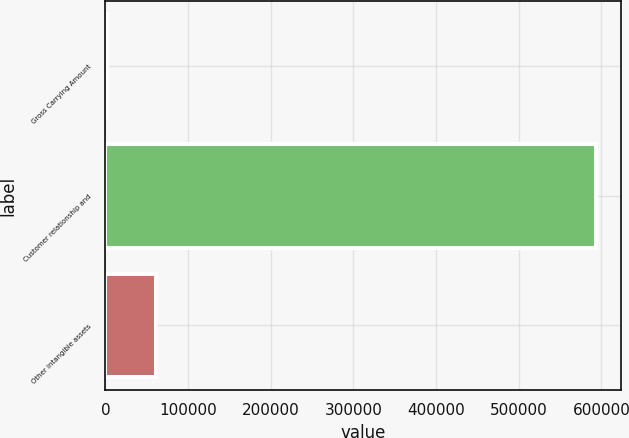<chart> <loc_0><loc_0><loc_500><loc_500><bar_chart><fcel>Gross Carrying Amount<fcel>Customer relationship and<fcel>Other intangible assets<nl><fcel>2011<fcel>593901<fcel>61200<nl></chart> 